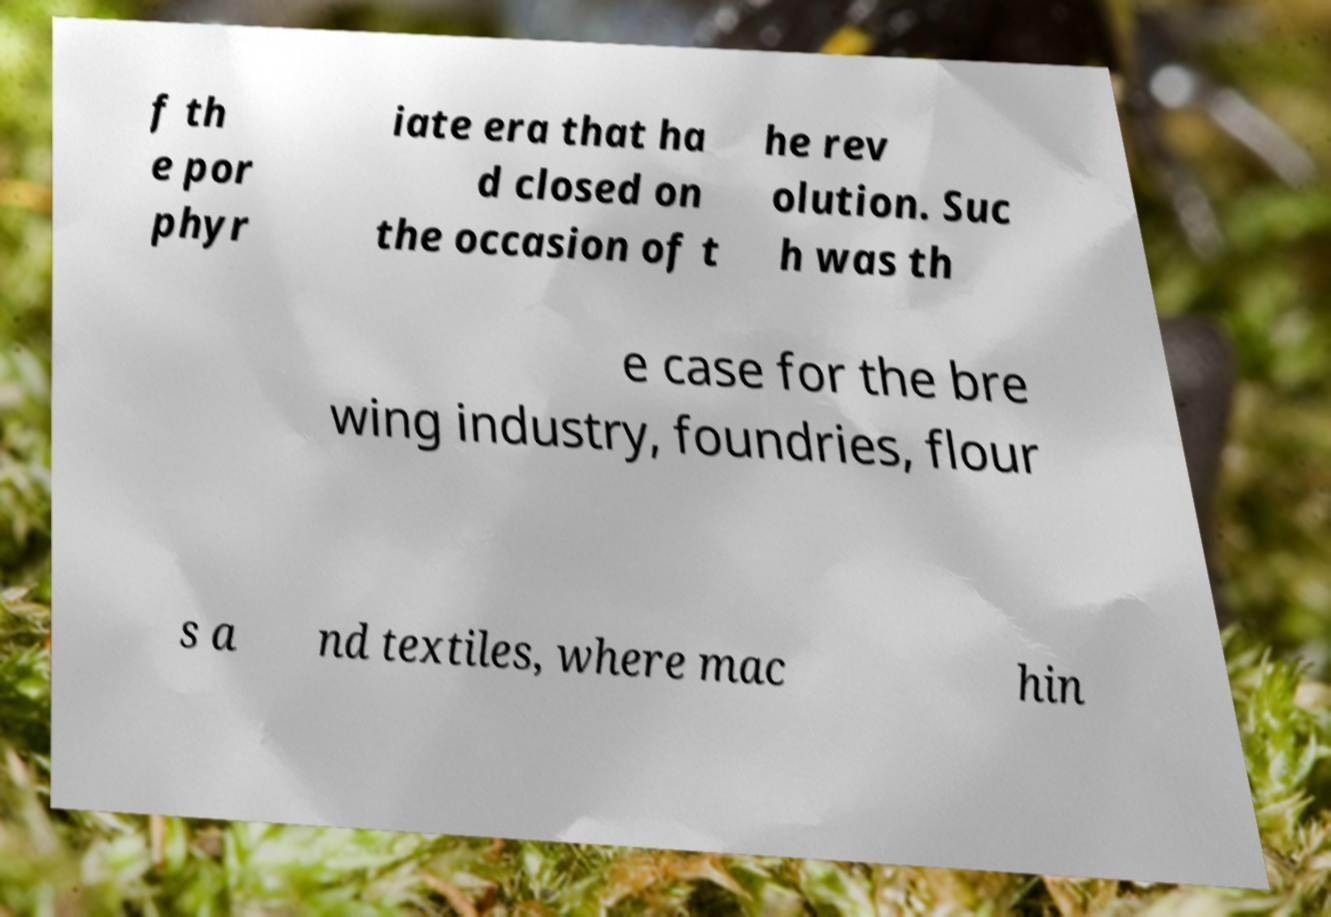There's text embedded in this image that I need extracted. Can you transcribe it verbatim? f th e por phyr iate era that ha d closed on the occasion of t he rev olution. Suc h was th e case for the bre wing industry, foundries, flour s a nd textiles, where mac hin 